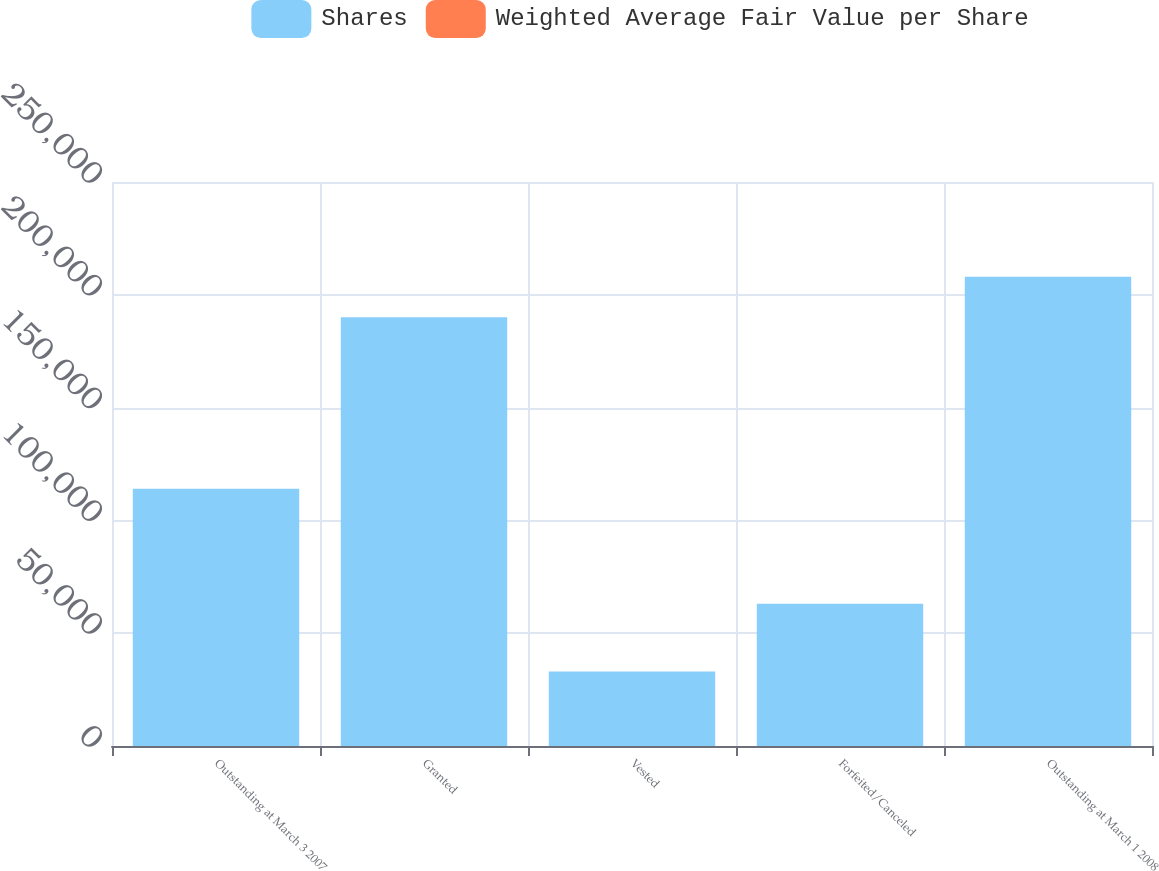Convert chart. <chart><loc_0><loc_0><loc_500><loc_500><stacked_bar_chart><ecel><fcel>Outstanding at March 3 2007<fcel>Granted<fcel>Vested<fcel>Forfeited/Canceled<fcel>Outstanding at March 1 2008<nl><fcel>Shares<fcel>114000<fcel>190000<fcel>33000<fcel>63000<fcel>208000<nl><fcel>Weighted Average Fair Value per Share<fcel>51.26<fcel>47.67<fcel>51.61<fcel>48.16<fcel>48.86<nl></chart> 